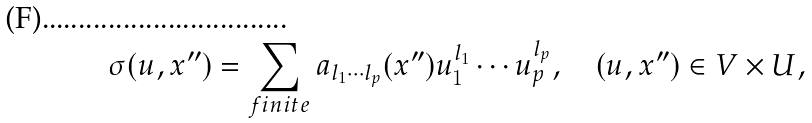<formula> <loc_0><loc_0><loc_500><loc_500>\sigma ( u , x ^ { \prime \prime } ) = \sum _ { f i n i t e } a _ { l _ { 1 } \cdots l _ { p } } ( x ^ { \prime \prime } ) u _ { 1 } ^ { l _ { 1 } } \cdots u _ { p } ^ { l _ { p } } , \quad ( u , x ^ { \prime \prime } ) \in V \times U ,</formula> 